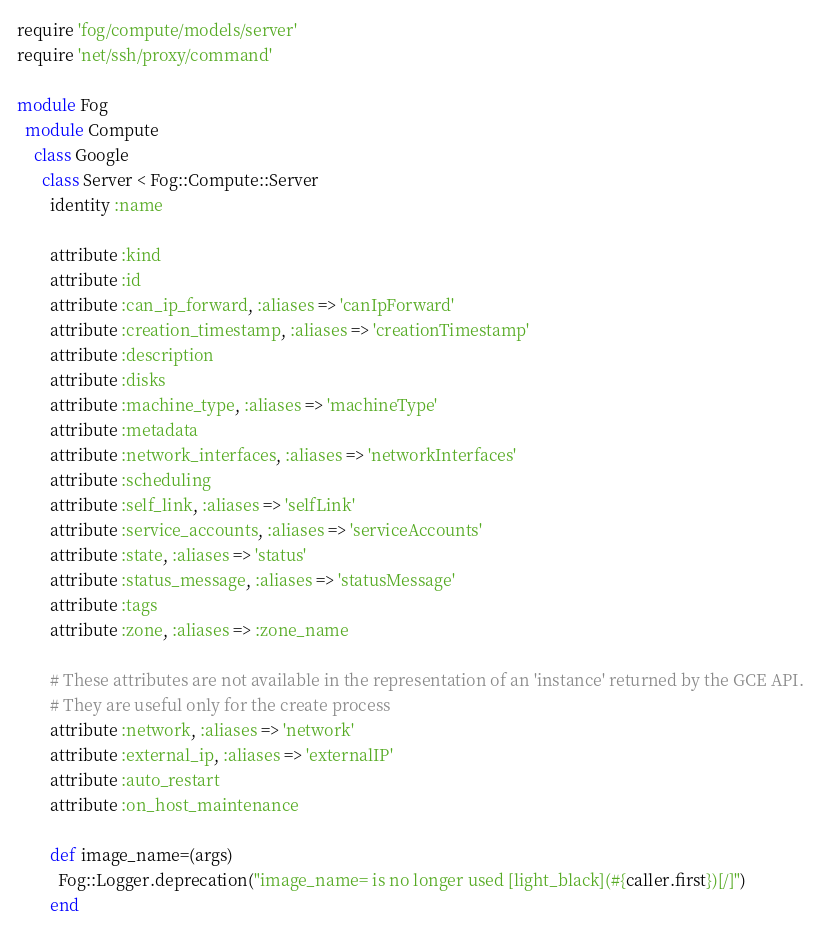<code> <loc_0><loc_0><loc_500><loc_500><_Ruby_>require 'fog/compute/models/server'
require 'net/ssh/proxy/command'

module Fog
  module Compute
    class Google
      class Server < Fog::Compute::Server
        identity :name

        attribute :kind
        attribute :id
        attribute :can_ip_forward, :aliases => 'canIpForward'
        attribute :creation_timestamp, :aliases => 'creationTimestamp'
        attribute :description
        attribute :disks
        attribute :machine_type, :aliases => 'machineType'
        attribute :metadata
        attribute :network_interfaces, :aliases => 'networkInterfaces'
        attribute :scheduling
        attribute :self_link, :aliases => 'selfLink'
        attribute :service_accounts, :aliases => 'serviceAccounts'
        attribute :state, :aliases => 'status'
        attribute :status_message, :aliases => 'statusMessage'
        attribute :tags
        attribute :zone, :aliases => :zone_name

        # These attributes are not available in the representation of an 'instance' returned by the GCE API.
        # They are useful only for the create process
        attribute :network, :aliases => 'network'
        attribute :external_ip, :aliases => 'externalIP'
        attribute :auto_restart
        attribute :on_host_maintenance

        def image_name=(args)
          Fog::Logger.deprecation("image_name= is no longer used [light_black](#{caller.first})[/]")
        end
</code> 